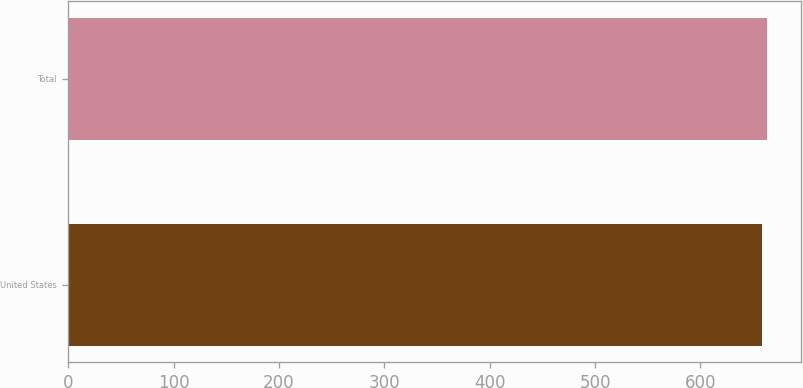Convert chart to OTSL. <chart><loc_0><loc_0><loc_500><loc_500><bar_chart><fcel>United States<fcel>Total<nl><fcel>658.5<fcel>662.7<nl></chart> 